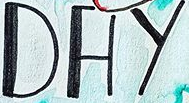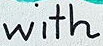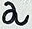Read the text from these images in sequence, separated by a semicolon. DAY; with; a 